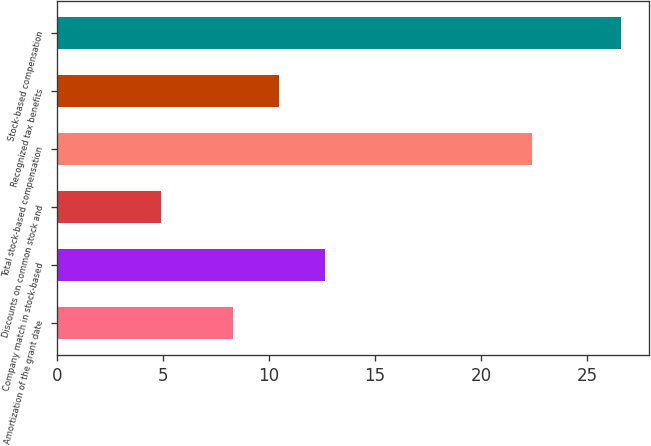Convert chart to OTSL. <chart><loc_0><loc_0><loc_500><loc_500><bar_chart><fcel>Amortization of the grant date<fcel>Company match in stock-based<fcel>Discounts on common stock and<fcel>Total stock-based compensation<fcel>Recognized tax benefits<fcel>Stock-based compensation<nl><fcel>8.3<fcel>12.64<fcel>4.9<fcel>22.4<fcel>10.47<fcel>26.6<nl></chart> 